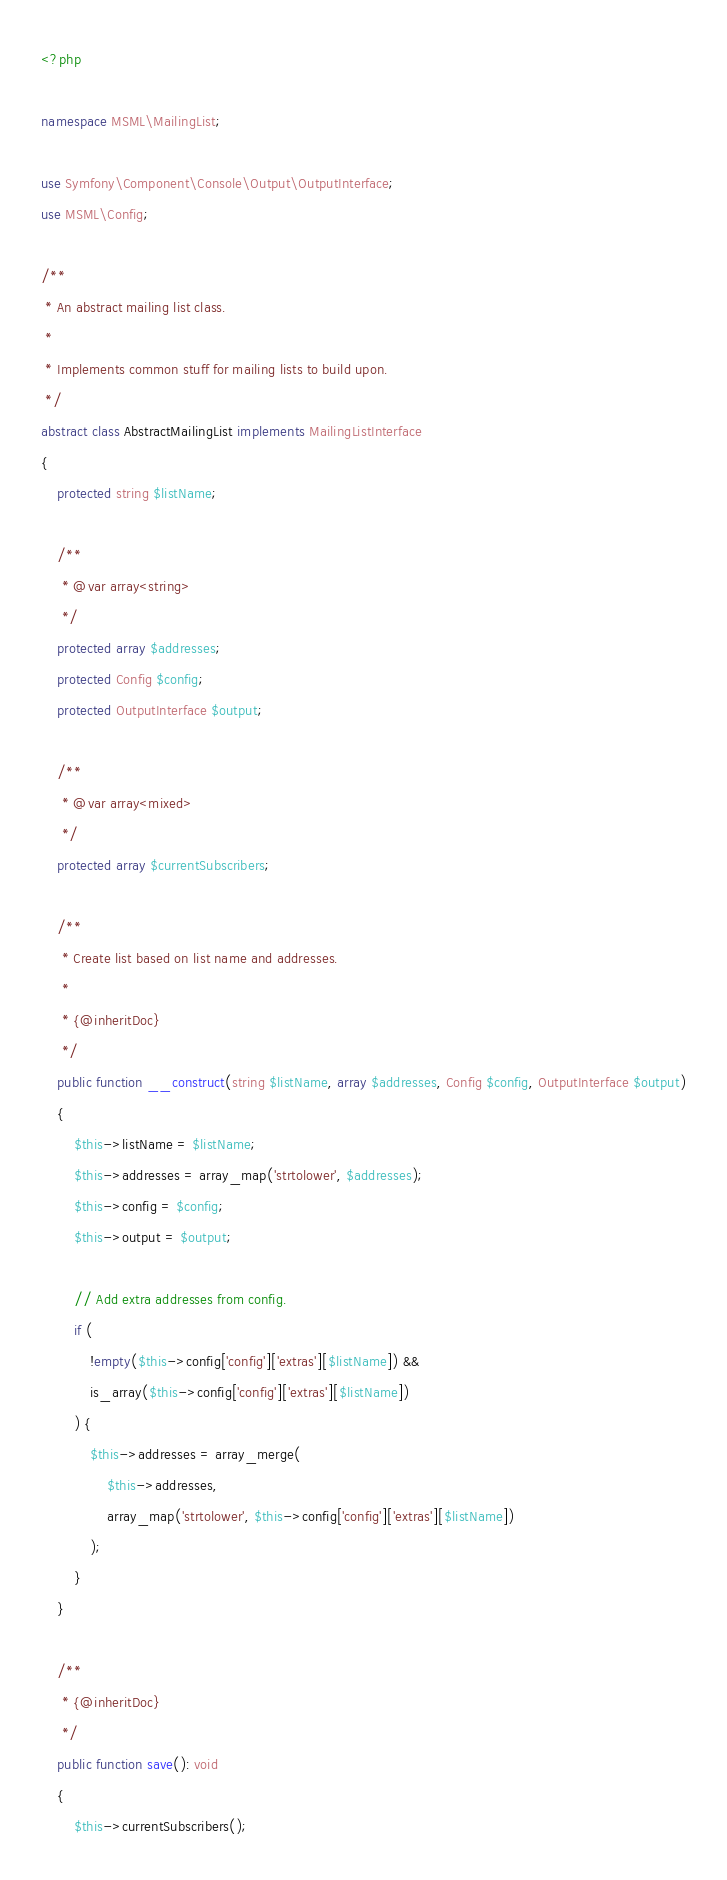<code> <loc_0><loc_0><loc_500><loc_500><_PHP_><?php

namespace MSML\MailingList;

use Symfony\Component\Console\Output\OutputInterface;
use MSML\Config;

/**
 * An abstract mailing list class.
 *
 * Implements common stuff for mailing lists to build upon.
 */
abstract class AbstractMailingList implements MailingListInterface
{
    protected string $listName;

    /**
     * @var array<string>
     */
    protected array $addresses;
    protected Config $config;
    protected OutputInterface $output;

    /**
     * @var array<mixed>
     */
    protected array $currentSubscribers;

    /**
     * Create list based on list name and addresses.
     *
     * {@inheritDoc}
     */
    public function __construct(string $listName, array $addresses, Config $config, OutputInterface $output)
    {
        $this->listName = $listName;
        $this->addresses = array_map('strtolower', $addresses);
        $this->config = $config;
        $this->output = $output;

        // Add extra addresses from config.
        if (
            !empty($this->config['config']['extras'][$listName]) &&
            is_array($this->config['config']['extras'][$listName])
        ) {
            $this->addresses = array_merge(
                $this->addresses,
                array_map('strtolower', $this->config['config']['extras'][$listName])
            );
        }
    }

    /**
     * {@inheritDoc}
     */
    public function save(): void
    {
        $this->currentSubscribers();
</code> 